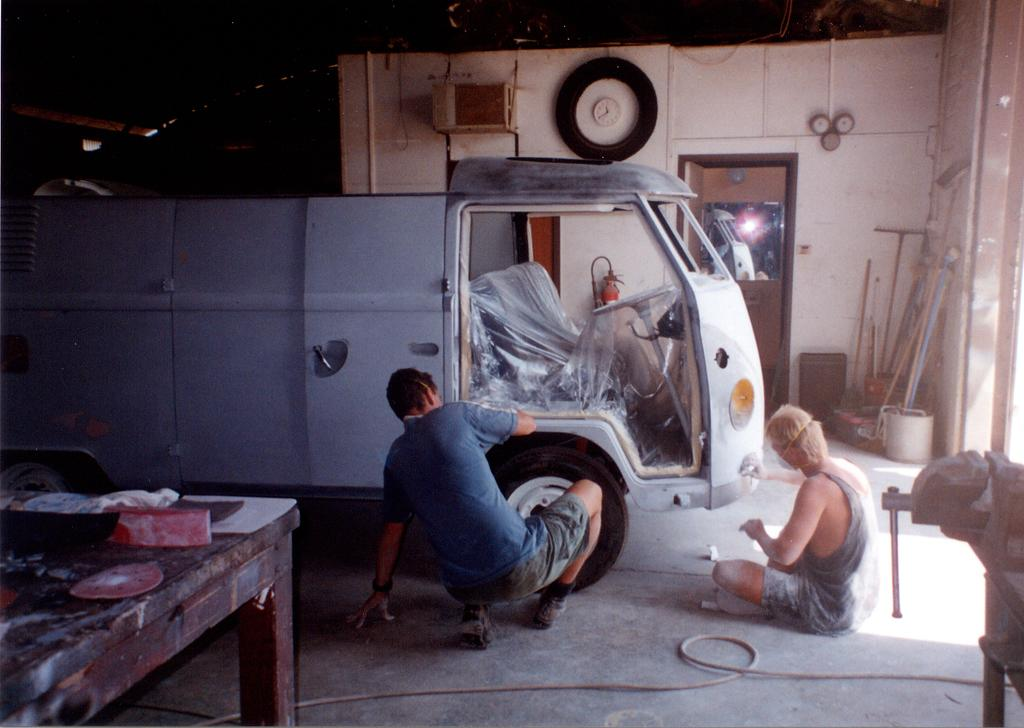How many people are present in the image? There are two people in the image. What are the two people doing in the image? The two people are painting a truck. Where are the rabbits hiding in the image? There are no rabbits present in the image. What type of veil is being used by one of the painters in the image? There is no veil present in the image; the two people are painting a truck without any additional accessories. 